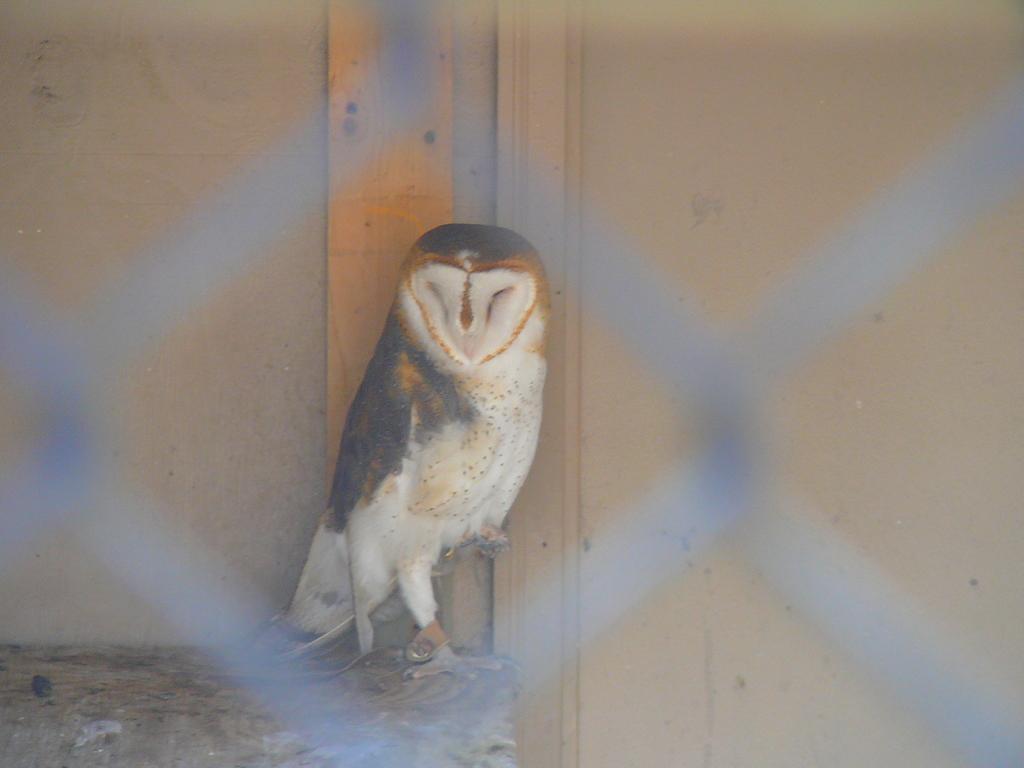Describe this image in one or two sentences. In this image there is a bird on the stone. In the background there is a wall. In front of the bird there is a grill. 